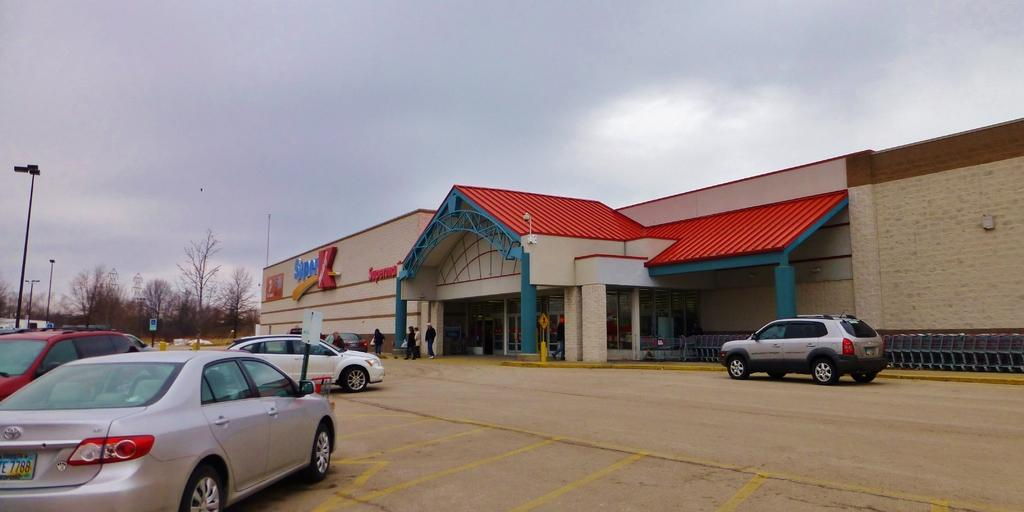What type of vehicles can be seen on the land in the image? There are cars on the land in the image. What can be seen in the background of the image? There are trees, at least one building, poles, lights, and people in the background of the image. What is visible at the top of the image? The sky is visible at the top of the image. What can be observed in the sky? There are clouds in the sky. Where is the queen sitting with her cub in the image? There is no queen or cub present in the image. 